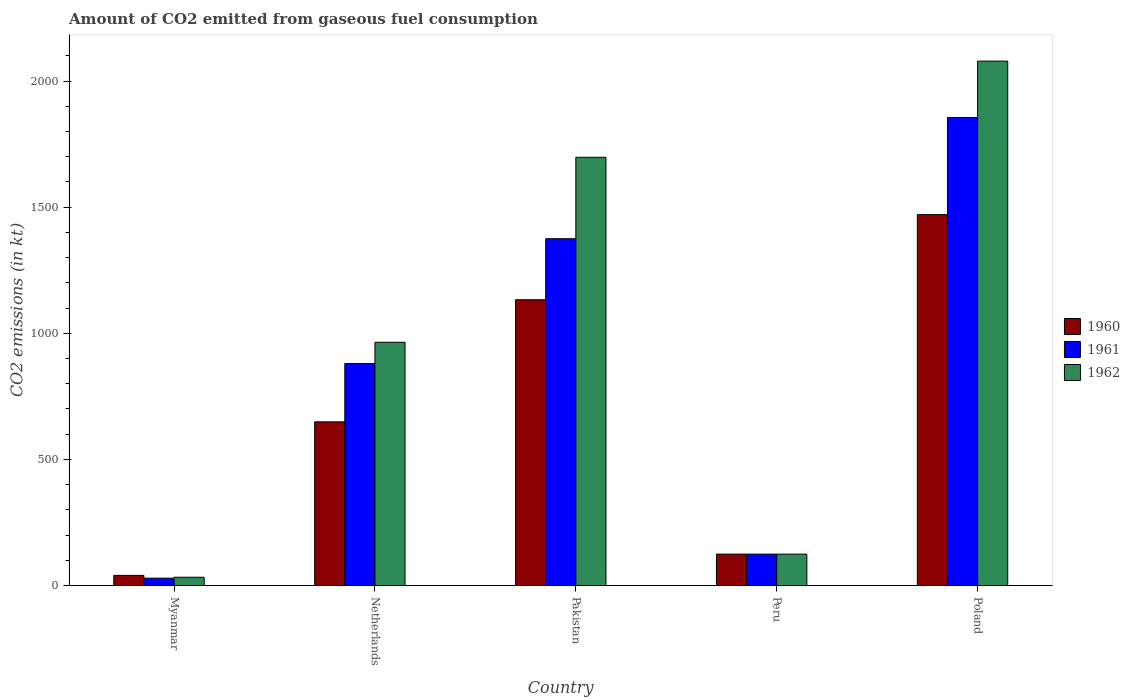How many different coloured bars are there?
Your response must be concise. 3. Are the number of bars per tick equal to the number of legend labels?
Your answer should be compact. Yes. Are the number of bars on each tick of the X-axis equal?
Offer a terse response. Yes. How many bars are there on the 5th tick from the right?
Provide a succinct answer. 3. What is the label of the 2nd group of bars from the left?
Give a very brief answer. Netherlands. What is the amount of CO2 emitted in 1962 in Pakistan?
Offer a terse response. 1697.82. Across all countries, what is the maximum amount of CO2 emitted in 1962?
Keep it short and to the point. 2079.19. Across all countries, what is the minimum amount of CO2 emitted in 1961?
Give a very brief answer. 29.34. In which country was the amount of CO2 emitted in 1961 minimum?
Provide a short and direct response. Myanmar. What is the total amount of CO2 emitted in 1961 in the graph?
Your answer should be compact. 4264.72. What is the difference between the amount of CO2 emitted in 1962 in Netherlands and that in Poland?
Your answer should be very brief. -1114.77. What is the difference between the amount of CO2 emitted in 1962 in Poland and the amount of CO2 emitted in 1961 in Pakistan?
Your response must be concise. 704.06. What is the average amount of CO2 emitted in 1960 per country?
Make the answer very short. 683.53. What is the difference between the amount of CO2 emitted of/in 1961 and amount of CO2 emitted of/in 1960 in Poland?
Keep it short and to the point. 385.03. In how many countries, is the amount of CO2 emitted in 1962 greater than 1600 kt?
Your response must be concise. 2. What is the ratio of the amount of CO2 emitted in 1960 in Myanmar to that in Pakistan?
Give a very brief answer. 0.04. Is the amount of CO2 emitted in 1962 in Pakistan less than that in Peru?
Make the answer very short. No. Is the difference between the amount of CO2 emitted in 1961 in Pakistan and Peru greater than the difference between the amount of CO2 emitted in 1960 in Pakistan and Peru?
Provide a succinct answer. Yes. What is the difference between the highest and the second highest amount of CO2 emitted in 1962?
Provide a short and direct response. 733.4. What is the difference between the highest and the lowest amount of CO2 emitted in 1962?
Ensure brevity in your answer.  2046.19. In how many countries, is the amount of CO2 emitted in 1962 greater than the average amount of CO2 emitted in 1962 taken over all countries?
Keep it short and to the point. 2. What does the 3rd bar from the right in Peru represents?
Give a very brief answer. 1960. Is it the case that in every country, the sum of the amount of CO2 emitted in 1961 and amount of CO2 emitted in 1960 is greater than the amount of CO2 emitted in 1962?
Provide a short and direct response. Yes. How many bars are there?
Your answer should be very brief. 15. What is the difference between two consecutive major ticks on the Y-axis?
Make the answer very short. 500. Are the values on the major ticks of Y-axis written in scientific E-notation?
Your answer should be compact. No. What is the title of the graph?
Offer a very short reply. Amount of CO2 emitted from gaseous fuel consumption. What is the label or title of the X-axis?
Provide a succinct answer. Country. What is the label or title of the Y-axis?
Provide a short and direct response. CO2 emissions (in kt). What is the CO2 emissions (in kt) in 1960 in Myanmar?
Provide a short and direct response. 40.34. What is the CO2 emissions (in kt) of 1961 in Myanmar?
Make the answer very short. 29.34. What is the CO2 emissions (in kt) in 1962 in Myanmar?
Make the answer very short. 33. What is the CO2 emissions (in kt) in 1960 in Netherlands?
Your answer should be compact. 649.06. What is the CO2 emissions (in kt) in 1961 in Netherlands?
Ensure brevity in your answer.  880.08. What is the CO2 emissions (in kt) of 1962 in Netherlands?
Offer a terse response. 964.42. What is the CO2 emissions (in kt) of 1960 in Pakistan?
Provide a succinct answer. 1133.1. What is the CO2 emissions (in kt) in 1961 in Pakistan?
Make the answer very short. 1375.12. What is the CO2 emissions (in kt) in 1962 in Pakistan?
Make the answer very short. 1697.82. What is the CO2 emissions (in kt) of 1960 in Peru?
Make the answer very short. 124.68. What is the CO2 emissions (in kt) of 1961 in Peru?
Give a very brief answer. 124.68. What is the CO2 emissions (in kt) of 1962 in Peru?
Ensure brevity in your answer.  124.68. What is the CO2 emissions (in kt) of 1960 in Poland?
Give a very brief answer. 1470.47. What is the CO2 emissions (in kt) of 1961 in Poland?
Offer a terse response. 1855.5. What is the CO2 emissions (in kt) in 1962 in Poland?
Offer a very short reply. 2079.19. Across all countries, what is the maximum CO2 emissions (in kt) of 1960?
Give a very brief answer. 1470.47. Across all countries, what is the maximum CO2 emissions (in kt) of 1961?
Make the answer very short. 1855.5. Across all countries, what is the maximum CO2 emissions (in kt) in 1962?
Give a very brief answer. 2079.19. Across all countries, what is the minimum CO2 emissions (in kt) of 1960?
Your response must be concise. 40.34. Across all countries, what is the minimum CO2 emissions (in kt) in 1961?
Your response must be concise. 29.34. Across all countries, what is the minimum CO2 emissions (in kt) in 1962?
Give a very brief answer. 33. What is the total CO2 emissions (in kt) of 1960 in the graph?
Offer a very short reply. 3417.64. What is the total CO2 emissions (in kt) in 1961 in the graph?
Ensure brevity in your answer.  4264.72. What is the total CO2 emissions (in kt) in 1962 in the graph?
Provide a succinct answer. 4899.11. What is the difference between the CO2 emissions (in kt) of 1960 in Myanmar and that in Netherlands?
Provide a short and direct response. -608.72. What is the difference between the CO2 emissions (in kt) of 1961 in Myanmar and that in Netherlands?
Your answer should be compact. -850.74. What is the difference between the CO2 emissions (in kt) of 1962 in Myanmar and that in Netherlands?
Your response must be concise. -931.42. What is the difference between the CO2 emissions (in kt) in 1960 in Myanmar and that in Pakistan?
Your response must be concise. -1092.77. What is the difference between the CO2 emissions (in kt) of 1961 in Myanmar and that in Pakistan?
Your answer should be very brief. -1345.79. What is the difference between the CO2 emissions (in kt) in 1962 in Myanmar and that in Pakistan?
Give a very brief answer. -1664.82. What is the difference between the CO2 emissions (in kt) in 1960 in Myanmar and that in Peru?
Your answer should be compact. -84.34. What is the difference between the CO2 emissions (in kt) of 1961 in Myanmar and that in Peru?
Offer a very short reply. -95.34. What is the difference between the CO2 emissions (in kt) in 1962 in Myanmar and that in Peru?
Your answer should be compact. -91.67. What is the difference between the CO2 emissions (in kt) in 1960 in Myanmar and that in Poland?
Your answer should be very brief. -1430.13. What is the difference between the CO2 emissions (in kt) of 1961 in Myanmar and that in Poland?
Ensure brevity in your answer.  -1826.17. What is the difference between the CO2 emissions (in kt) of 1962 in Myanmar and that in Poland?
Offer a terse response. -2046.19. What is the difference between the CO2 emissions (in kt) in 1960 in Netherlands and that in Pakistan?
Give a very brief answer. -484.04. What is the difference between the CO2 emissions (in kt) in 1961 in Netherlands and that in Pakistan?
Your response must be concise. -495.05. What is the difference between the CO2 emissions (in kt) in 1962 in Netherlands and that in Pakistan?
Offer a very short reply. -733.4. What is the difference between the CO2 emissions (in kt) in 1960 in Netherlands and that in Peru?
Give a very brief answer. 524.38. What is the difference between the CO2 emissions (in kt) of 1961 in Netherlands and that in Peru?
Give a very brief answer. 755.4. What is the difference between the CO2 emissions (in kt) in 1962 in Netherlands and that in Peru?
Your answer should be very brief. 839.74. What is the difference between the CO2 emissions (in kt) of 1960 in Netherlands and that in Poland?
Your answer should be compact. -821.41. What is the difference between the CO2 emissions (in kt) of 1961 in Netherlands and that in Poland?
Make the answer very short. -975.42. What is the difference between the CO2 emissions (in kt) in 1962 in Netherlands and that in Poland?
Offer a terse response. -1114.77. What is the difference between the CO2 emissions (in kt) in 1960 in Pakistan and that in Peru?
Ensure brevity in your answer.  1008.42. What is the difference between the CO2 emissions (in kt) in 1961 in Pakistan and that in Peru?
Offer a terse response. 1250.45. What is the difference between the CO2 emissions (in kt) in 1962 in Pakistan and that in Peru?
Your response must be concise. 1573.14. What is the difference between the CO2 emissions (in kt) in 1960 in Pakistan and that in Poland?
Give a very brief answer. -337.36. What is the difference between the CO2 emissions (in kt) in 1961 in Pakistan and that in Poland?
Make the answer very short. -480.38. What is the difference between the CO2 emissions (in kt) of 1962 in Pakistan and that in Poland?
Keep it short and to the point. -381.37. What is the difference between the CO2 emissions (in kt) in 1960 in Peru and that in Poland?
Provide a short and direct response. -1345.79. What is the difference between the CO2 emissions (in kt) in 1961 in Peru and that in Poland?
Offer a very short reply. -1730.82. What is the difference between the CO2 emissions (in kt) in 1962 in Peru and that in Poland?
Ensure brevity in your answer.  -1954.51. What is the difference between the CO2 emissions (in kt) in 1960 in Myanmar and the CO2 emissions (in kt) in 1961 in Netherlands?
Ensure brevity in your answer.  -839.74. What is the difference between the CO2 emissions (in kt) of 1960 in Myanmar and the CO2 emissions (in kt) of 1962 in Netherlands?
Offer a very short reply. -924.08. What is the difference between the CO2 emissions (in kt) of 1961 in Myanmar and the CO2 emissions (in kt) of 1962 in Netherlands?
Provide a succinct answer. -935.09. What is the difference between the CO2 emissions (in kt) in 1960 in Myanmar and the CO2 emissions (in kt) in 1961 in Pakistan?
Provide a short and direct response. -1334.79. What is the difference between the CO2 emissions (in kt) in 1960 in Myanmar and the CO2 emissions (in kt) in 1962 in Pakistan?
Give a very brief answer. -1657.48. What is the difference between the CO2 emissions (in kt) in 1961 in Myanmar and the CO2 emissions (in kt) in 1962 in Pakistan?
Offer a terse response. -1668.48. What is the difference between the CO2 emissions (in kt) in 1960 in Myanmar and the CO2 emissions (in kt) in 1961 in Peru?
Make the answer very short. -84.34. What is the difference between the CO2 emissions (in kt) of 1960 in Myanmar and the CO2 emissions (in kt) of 1962 in Peru?
Make the answer very short. -84.34. What is the difference between the CO2 emissions (in kt) in 1961 in Myanmar and the CO2 emissions (in kt) in 1962 in Peru?
Offer a terse response. -95.34. What is the difference between the CO2 emissions (in kt) of 1960 in Myanmar and the CO2 emissions (in kt) of 1961 in Poland?
Give a very brief answer. -1815.16. What is the difference between the CO2 emissions (in kt) of 1960 in Myanmar and the CO2 emissions (in kt) of 1962 in Poland?
Keep it short and to the point. -2038.85. What is the difference between the CO2 emissions (in kt) in 1961 in Myanmar and the CO2 emissions (in kt) in 1962 in Poland?
Keep it short and to the point. -2049.85. What is the difference between the CO2 emissions (in kt) in 1960 in Netherlands and the CO2 emissions (in kt) in 1961 in Pakistan?
Provide a short and direct response. -726.07. What is the difference between the CO2 emissions (in kt) of 1960 in Netherlands and the CO2 emissions (in kt) of 1962 in Pakistan?
Offer a terse response. -1048.76. What is the difference between the CO2 emissions (in kt) of 1961 in Netherlands and the CO2 emissions (in kt) of 1962 in Pakistan?
Your response must be concise. -817.74. What is the difference between the CO2 emissions (in kt) of 1960 in Netherlands and the CO2 emissions (in kt) of 1961 in Peru?
Provide a short and direct response. 524.38. What is the difference between the CO2 emissions (in kt) in 1960 in Netherlands and the CO2 emissions (in kt) in 1962 in Peru?
Ensure brevity in your answer.  524.38. What is the difference between the CO2 emissions (in kt) of 1961 in Netherlands and the CO2 emissions (in kt) of 1962 in Peru?
Make the answer very short. 755.4. What is the difference between the CO2 emissions (in kt) in 1960 in Netherlands and the CO2 emissions (in kt) in 1961 in Poland?
Offer a very short reply. -1206.44. What is the difference between the CO2 emissions (in kt) in 1960 in Netherlands and the CO2 emissions (in kt) in 1962 in Poland?
Provide a succinct answer. -1430.13. What is the difference between the CO2 emissions (in kt) in 1961 in Netherlands and the CO2 emissions (in kt) in 1962 in Poland?
Offer a terse response. -1199.11. What is the difference between the CO2 emissions (in kt) of 1960 in Pakistan and the CO2 emissions (in kt) of 1961 in Peru?
Offer a terse response. 1008.42. What is the difference between the CO2 emissions (in kt) of 1960 in Pakistan and the CO2 emissions (in kt) of 1962 in Peru?
Provide a succinct answer. 1008.42. What is the difference between the CO2 emissions (in kt) of 1961 in Pakistan and the CO2 emissions (in kt) of 1962 in Peru?
Ensure brevity in your answer.  1250.45. What is the difference between the CO2 emissions (in kt) in 1960 in Pakistan and the CO2 emissions (in kt) in 1961 in Poland?
Ensure brevity in your answer.  -722.4. What is the difference between the CO2 emissions (in kt) in 1960 in Pakistan and the CO2 emissions (in kt) in 1962 in Poland?
Offer a very short reply. -946.09. What is the difference between the CO2 emissions (in kt) in 1961 in Pakistan and the CO2 emissions (in kt) in 1962 in Poland?
Your answer should be very brief. -704.06. What is the difference between the CO2 emissions (in kt) of 1960 in Peru and the CO2 emissions (in kt) of 1961 in Poland?
Give a very brief answer. -1730.82. What is the difference between the CO2 emissions (in kt) of 1960 in Peru and the CO2 emissions (in kt) of 1962 in Poland?
Your response must be concise. -1954.51. What is the difference between the CO2 emissions (in kt) of 1961 in Peru and the CO2 emissions (in kt) of 1962 in Poland?
Offer a very short reply. -1954.51. What is the average CO2 emissions (in kt) in 1960 per country?
Make the answer very short. 683.53. What is the average CO2 emissions (in kt) in 1961 per country?
Your answer should be compact. 852.94. What is the average CO2 emissions (in kt) in 1962 per country?
Your answer should be very brief. 979.82. What is the difference between the CO2 emissions (in kt) of 1960 and CO2 emissions (in kt) of 1961 in Myanmar?
Offer a very short reply. 11. What is the difference between the CO2 emissions (in kt) of 1960 and CO2 emissions (in kt) of 1962 in Myanmar?
Your answer should be very brief. 7.33. What is the difference between the CO2 emissions (in kt) of 1961 and CO2 emissions (in kt) of 1962 in Myanmar?
Offer a terse response. -3.67. What is the difference between the CO2 emissions (in kt) in 1960 and CO2 emissions (in kt) in 1961 in Netherlands?
Make the answer very short. -231.02. What is the difference between the CO2 emissions (in kt) of 1960 and CO2 emissions (in kt) of 1962 in Netherlands?
Provide a succinct answer. -315.36. What is the difference between the CO2 emissions (in kt) of 1961 and CO2 emissions (in kt) of 1962 in Netherlands?
Provide a succinct answer. -84.34. What is the difference between the CO2 emissions (in kt) in 1960 and CO2 emissions (in kt) in 1961 in Pakistan?
Your answer should be very brief. -242.02. What is the difference between the CO2 emissions (in kt) in 1960 and CO2 emissions (in kt) in 1962 in Pakistan?
Make the answer very short. -564.72. What is the difference between the CO2 emissions (in kt) in 1961 and CO2 emissions (in kt) in 1962 in Pakistan?
Offer a very short reply. -322.7. What is the difference between the CO2 emissions (in kt) of 1961 and CO2 emissions (in kt) of 1962 in Peru?
Your response must be concise. 0. What is the difference between the CO2 emissions (in kt) in 1960 and CO2 emissions (in kt) in 1961 in Poland?
Your answer should be very brief. -385.04. What is the difference between the CO2 emissions (in kt) of 1960 and CO2 emissions (in kt) of 1962 in Poland?
Provide a short and direct response. -608.72. What is the difference between the CO2 emissions (in kt) of 1961 and CO2 emissions (in kt) of 1962 in Poland?
Keep it short and to the point. -223.69. What is the ratio of the CO2 emissions (in kt) of 1960 in Myanmar to that in Netherlands?
Offer a terse response. 0.06. What is the ratio of the CO2 emissions (in kt) of 1961 in Myanmar to that in Netherlands?
Provide a succinct answer. 0.03. What is the ratio of the CO2 emissions (in kt) in 1962 in Myanmar to that in Netherlands?
Give a very brief answer. 0.03. What is the ratio of the CO2 emissions (in kt) of 1960 in Myanmar to that in Pakistan?
Provide a succinct answer. 0.04. What is the ratio of the CO2 emissions (in kt) of 1961 in Myanmar to that in Pakistan?
Your response must be concise. 0.02. What is the ratio of the CO2 emissions (in kt) of 1962 in Myanmar to that in Pakistan?
Provide a short and direct response. 0.02. What is the ratio of the CO2 emissions (in kt) in 1960 in Myanmar to that in Peru?
Provide a succinct answer. 0.32. What is the ratio of the CO2 emissions (in kt) of 1961 in Myanmar to that in Peru?
Your answer should be compact. 0.24. What is the ratio of the CO2 emissions (in kt) in 1962 in Myanmar to that in Peru?
Offer a very short reply. 0.26. What is the ratio of the CO2 emissions (in kt) of 1960 in Myanmar to that in Poland?
Your answer should be very brief. 0.03. What is the ratio of the CO2 emissions (in kt) in 1961 in Myanmar to that in Poland?
Make the answer very short. 0.02. What is the ratio of the CO2 emissions (in kt) of 1962 in Myanmar to that in Poland?
Offer a very short reply. 0.02. What is the ratio of the CO2 emissions (in kt) in 1960 in Netherlands to that in Pakistan?
Offer a terse response. 0.57. What is the ratio of the CO2 emissions (in kt) in 1961 in Netherlands to that in Pakistan?
Your answer should be very brief. 0.64. What is the ratio of the CO2 emissions (in kt) in 1962 in Netherlands to that in Pakistan?
Ensure brevity in your answer.  0.57. What is the ratio of the CO2 emissions (in kt) of 1960 in Netherlands to that in Peru?
Offer a terse response. 5.21. What is the ratio of the CO2 emissions (in kt) of 1961 in Netherlands to that in Peru?
Provide a succinct answer. 7.06. What is the ratio of the CO2 emissions (in kt) in 1962 in Netherlands to that in Peru?
Keep it short and to the point. 7.74. What is the ratio of the CO2 emissions (in kt) of 1960 in Netherlands to that in Poland?
Provide a short and direct response. 0.44. What is the ratio of the CO2 emissions (in kt) of 1961 in Netherlands to that in Poland?
Ensure brevity in your answer.  0.47. What is the ratio of the CO2 emissions (in kt) of 1962 in Netherlands to that in Poland?
Your response must be concise. 0.46. What is the ratio of the CO2 emissions (in kt) of 1960 in Pakistan to that in Peru?
Give a very brief answer. 9.09. What is the ratio of the CO2 emissions (in kt) in 1961 in Pakistan to that in Peru?
Provide a short and direct response. 11.03. What is the ratio of the CO2 emissions (in kt) in 1962 in Pakistan to that in Peru?
Offer a very short reply. 13.62. What is the ratio of the CO2 emissions (in kt) of 1960 in Pakistan to that in Poland?
Your answer should be compact. 0.77. What is the ratio of the CO2 emissions (in kt) of 1961 in Pakistan to that in Poland?
Your response must be concise. 0.74. What is the ratio of the CO2 emissions (in kt) of 1962 in Pakistan to that in Poland?
Your answer should be very brief. 0.82. What is the ratio of the CO2 emissions (in kt) in 1960 in Peru to that in Poland?
Ensure brevity in your answer.  0.08. What is the ratio of the CO2 emissions (in kt) in 1961 in Peru to that in Poland?
Offer a very short reply. 0.07. What is the ratio of the CO2 emissions (in kt) in 1962 in Peru to that in Poland?
Offer a terse response. 0.06. What is the difference between the highest and the second highest CO2 emissions (in kt) of 1960?
Provide a short and direct response. 337.36. What is the difference between the highest and the second highest CO2 emissions (in kt) in 1961?
Provide a short and direct response. 480.38. What is the difference between the highest and the second highest CO2 emissions (in kt) in 1962?
Your answer should be compact. 381.37. What is the difference between the highest and the lowest CO2 emissions (in kt) in 1960?
Provide a short and direct response. 1430.13. What is the difference between the highest and the lowest CO2 emissions (in kt) in 1961?
Ensure brevity in your answer.  1826.17. What is the difference between the highest and the lowest CO2 emissions (in kt) of 1962?
Offer a very short reply. 2046.19. 